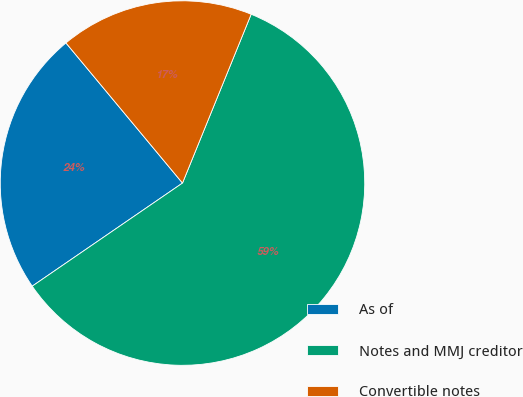<chart> <loc_0><loc_0><loc_500><loc_500><pie_chart><fcel>As of<fcel>Notes and MMJ creditor<fcel>Convertible notes<nl><fcel>23.53%<fcel>59.28%<fcel>17.19%<nl></chart> 